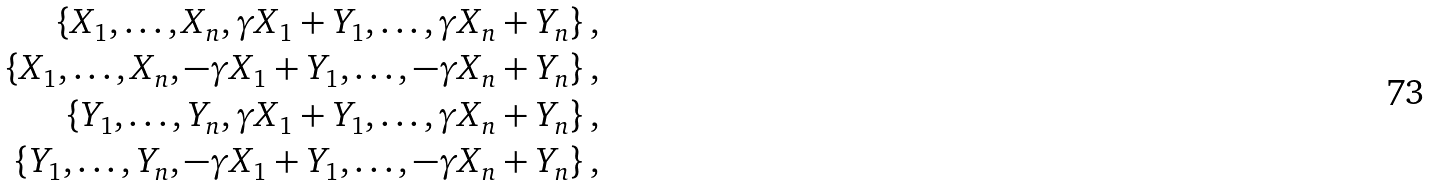Convert formula to latex. <formula><loc_0><loc_0><loc_500><loc_500>\left \{ X _ { 1 } , \dots , X _ { n } , \gamma X _ { 1 } + Y _ { 1 } , \dots , \gamma X _ { n } + Y _ { n } \right \} , \\ \left \{ X _ { 1 } , \dots , X _ { n } , - \gamma X _ { 1 } + Y _ { 1 } , \dots , - \gamma X _ { n } + Y _ { n } \right \} , \\ \left \{ Y _ { 1 } , \dots , Y _ { n } , \gamma X _ { 1 } + Y _ { 1 } , \dots , \gamma X _ { n } + Y _ { n } \right \} , \\ \left \{ Y _ { 1 } , \dots , Y _ { n } , - \gamma X _ { 1 } + Y _ { 1 } , \dots , - \gamma X _ { n } + Y _ { n } \right \} ,</formula> 